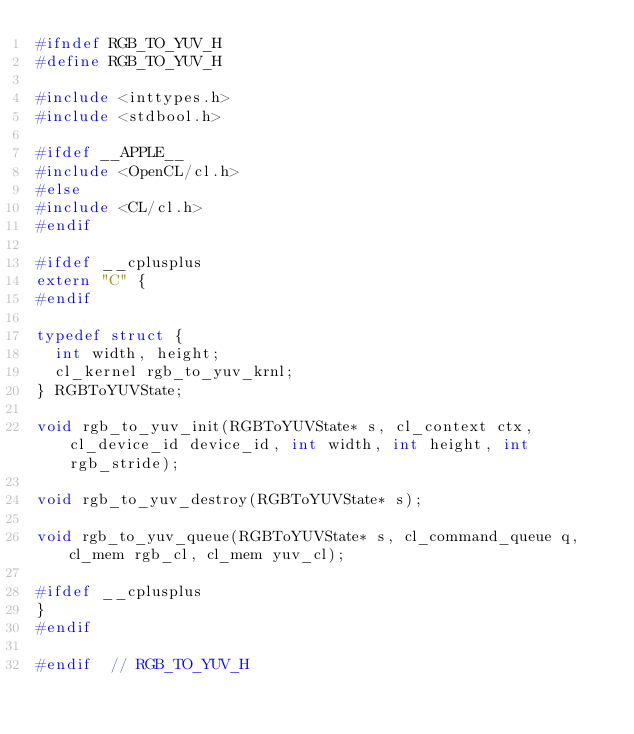<code> <loc_0><loc_0><loc_500><loc_500><_C_>#ifndef RGB_TO_YUV_H
#define RGB_TO_YUV_H

#include <inttypes.h>
#include <stdbool.h>

#ifdef __APPLE__
#include <OpenCL/cl.h>
#else
#include <CL/cl.h>
#endif

#ifdef __cplusplus
extern "C" {
#endif

typedef struct {
  int width, height;
  cl_kernel rgb_to_yuv_krnl;
} RGBToYUVState;

void rgb_to_yuv_init(RGBToYUVState* s, cl_context ctx, cl_device_id device_id, int width, int height, int rgb_stride);

void rgb_to_yuv_destroy(RGBToYUVState* s);

void rgb_to_yuv_queue(RGBToYUVState* s, cl_command_queue q, cl_mem rgb_cl, cl_mem yuv_cl);

#ifdef __cplusplus
}
#endif

#endif  // RGB_TO_YUV_H
</code> 